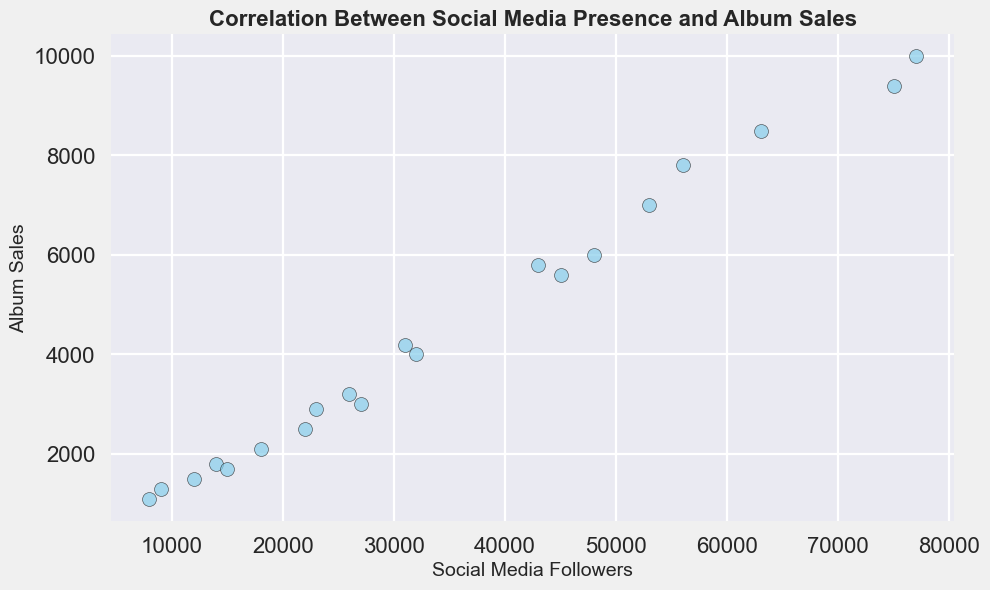What is the relationship between social media followers and album sales? Observing the scatter plot, there is a general upward trend indicating that as the number of social media followers increases, album sales also tend to increase.
Answer: Positive correlation Which artist has the highest album sales, and how many social media followers do they have? The artist with the highest album sales has 10,000 sales and has around 77,000 social media followers according to the plot.
Answer: 77,000 followers Identify the artist with 32,000 social media followers. What are their album sales? Find the point corresponding to 32,000 followers on the x-axis and look at the y-axis value. The album sales for the artist with 32,000 followers are 4,000.
Answer: 4,000 album sales Is there any artist with album sales of 1,800? If so, how many followers do they have? Locate the point at 1,800 on the y-axis and then trace it back to the x-axis to find the social media followers. This artist has around 14,000 followers.
Answer: 14,000 followers Which artist has more album sales: the one with 45,000 followers or the one with 27,000 followers? Compare the y-values for the points 45,000 and 27,000 on the x-axis. The artist with 45,000 followers has around 5,600 sales, while the artist with 27,000 followers has around 3,000 sales. Therefore, the artist with 45,000 followers has more album sales.
Answer: 45,000 followers artist Determine the average album sales for artists with over 50,000 followers. Collect the album sales for artists with followers over 50,000: 7,800, 8,500, 9,400, 10,000. Sum these values: 7,800 + 8,500 + 9,400 + 10,000 = 35,700. There are 4 data points, so the average is 35,700 / 4 = 8,925.
Answer: 8,925 sales Is there any point that visibly deviates from the general trend? If yes, describe it. Check for points that do not fit the general upward trend line. The point at 8,000 followers and 1,100 sales is noticeably lower than expected based on the trend.
Answer: 8,000 followers, 1,100 sales Which artist has similar album sales to the one with 56,000 followers, and how many social media followers does this artist have? The artist with 56,000 followers has 7,800 sales. Find another point close to 7,800 on the y-axis and check the x-axis value. The artist with 53,000 followers has similar album sales (7,000).
Answer: 53,000 followers Calculate the difference in album sales between artists with 31,000 followers and 22,000 followers. Identify the album sales: 4,200 for 31,000 followers and 2,500 for 22,000 followers. Subtract 2,500 from 4,200 to get the difference: 4,200 - 2,500 = 1,700.
Answer: 1,700 sales What is the median number of album sales among all artists? To find the median, list all album sales in ascending order: 1,100, 1,300, 1,500, 1,700, 1,800, 2,100, 2,500, 2,900, 3,000, 3,200, 4,000, 4,200, 5,600, 5,800, 6,000, 7,000, 7,800, 8,500, 9,400, 10,000. The median value (middle value of this sorted list) is at the 10th and 11th positions: (3,200 + 4,000) / 2 = 3,600.
Answer: 3,600 sales 